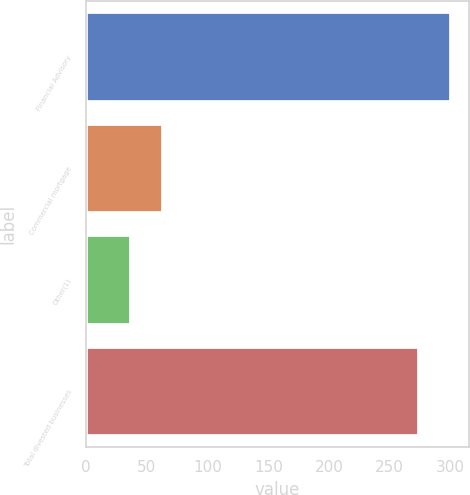Convert chart to OTSL. <chart><loc_0><loc_0><loc_500><loc_500><bar_chart><fcel>Financial Advisory<fcel>Commercial mortgage<fcel>Other(1)<fcel>Total divested businesses<nl><fcel>300.3<fcel>63.3<fcel>37<fcel>274<nl></chart> 